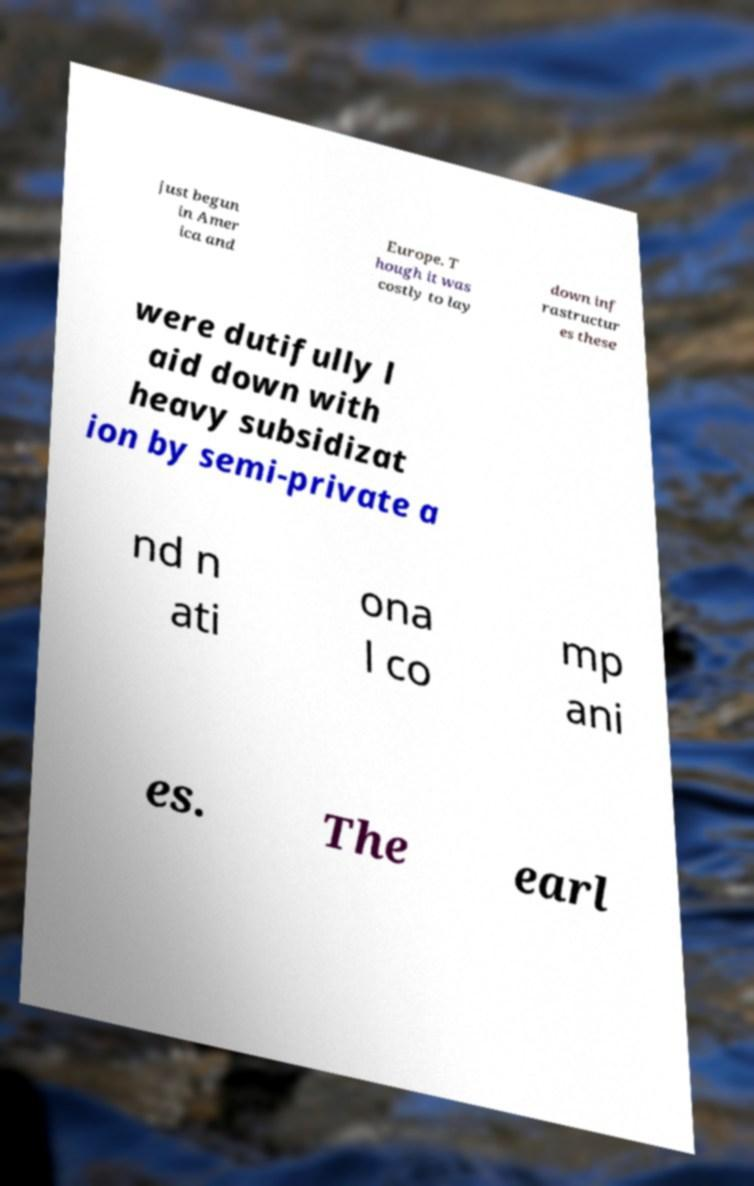Could you extract and type out the text from this image? just begun in Amer ica and Europe. T hough it was costly to lay down inf rastructur es these were dutifully l aid down with heavy subsidizat ion by semi-private a nd n ati ona l co mp ani es. The earl 